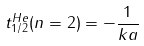<formula> <loc_0><loc_0><loc_500><loc_500>t _ { 1 / 2 } ^ { H e } ( n = 2 ) = - \frac { 1 } { k a }</formula> 